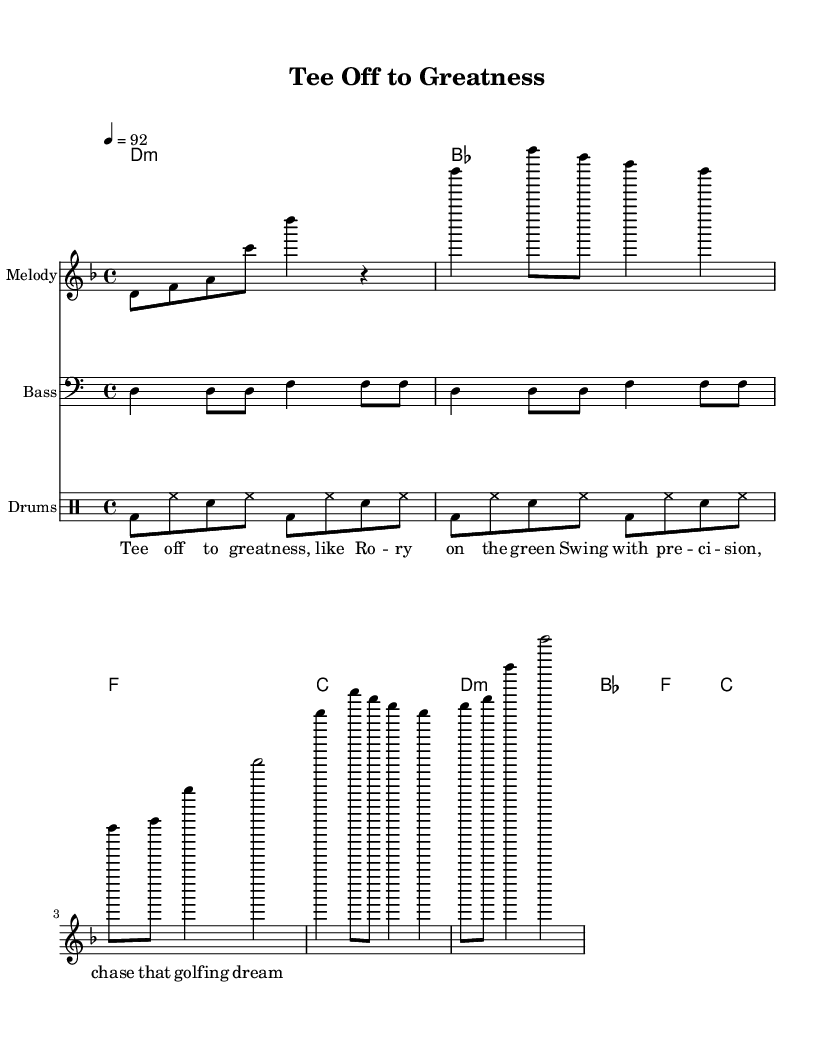What is the key signature of this music? The key signature is D minor, indicated by the one flat in the music, which corresponds to the notes used.
Answer: D minor What is the time signature of this music? The time signature is 4/4, as shown near the beginning of the music. This means there are four beats per measure.
Answer: 4/4 What is the tempo marking for this piece? The tempo marking is given as 92 beats per minute, indicated at the start of the sheet music within the global block.
Answer: 92 How many measures are in the chorus section? The chorus consists of four measures, each having a repeated structure as noted in the sheet music.
Answer: 4 What type of musical form is represented in this piece? The music features a repetitive structure characteristic of rap, with a clear chorus that is repeated multiple times. The repeated musical elements support the lyrical content focused on motivation.
Answer: Repetitive Which section of the music includes lyrics? The lyrics are specifically included in the "Lyrics" staff, which is below the melody and shows the motivational theme in the rap.
Answer: Lyrics What is the role of the bass line in this rap? The bass line provides a foundational rhythmic and harmonic support, emphasizing the downbeats and complementing the melody, essential for creating the groove typical in rap music.
Answer: Harmonic support 